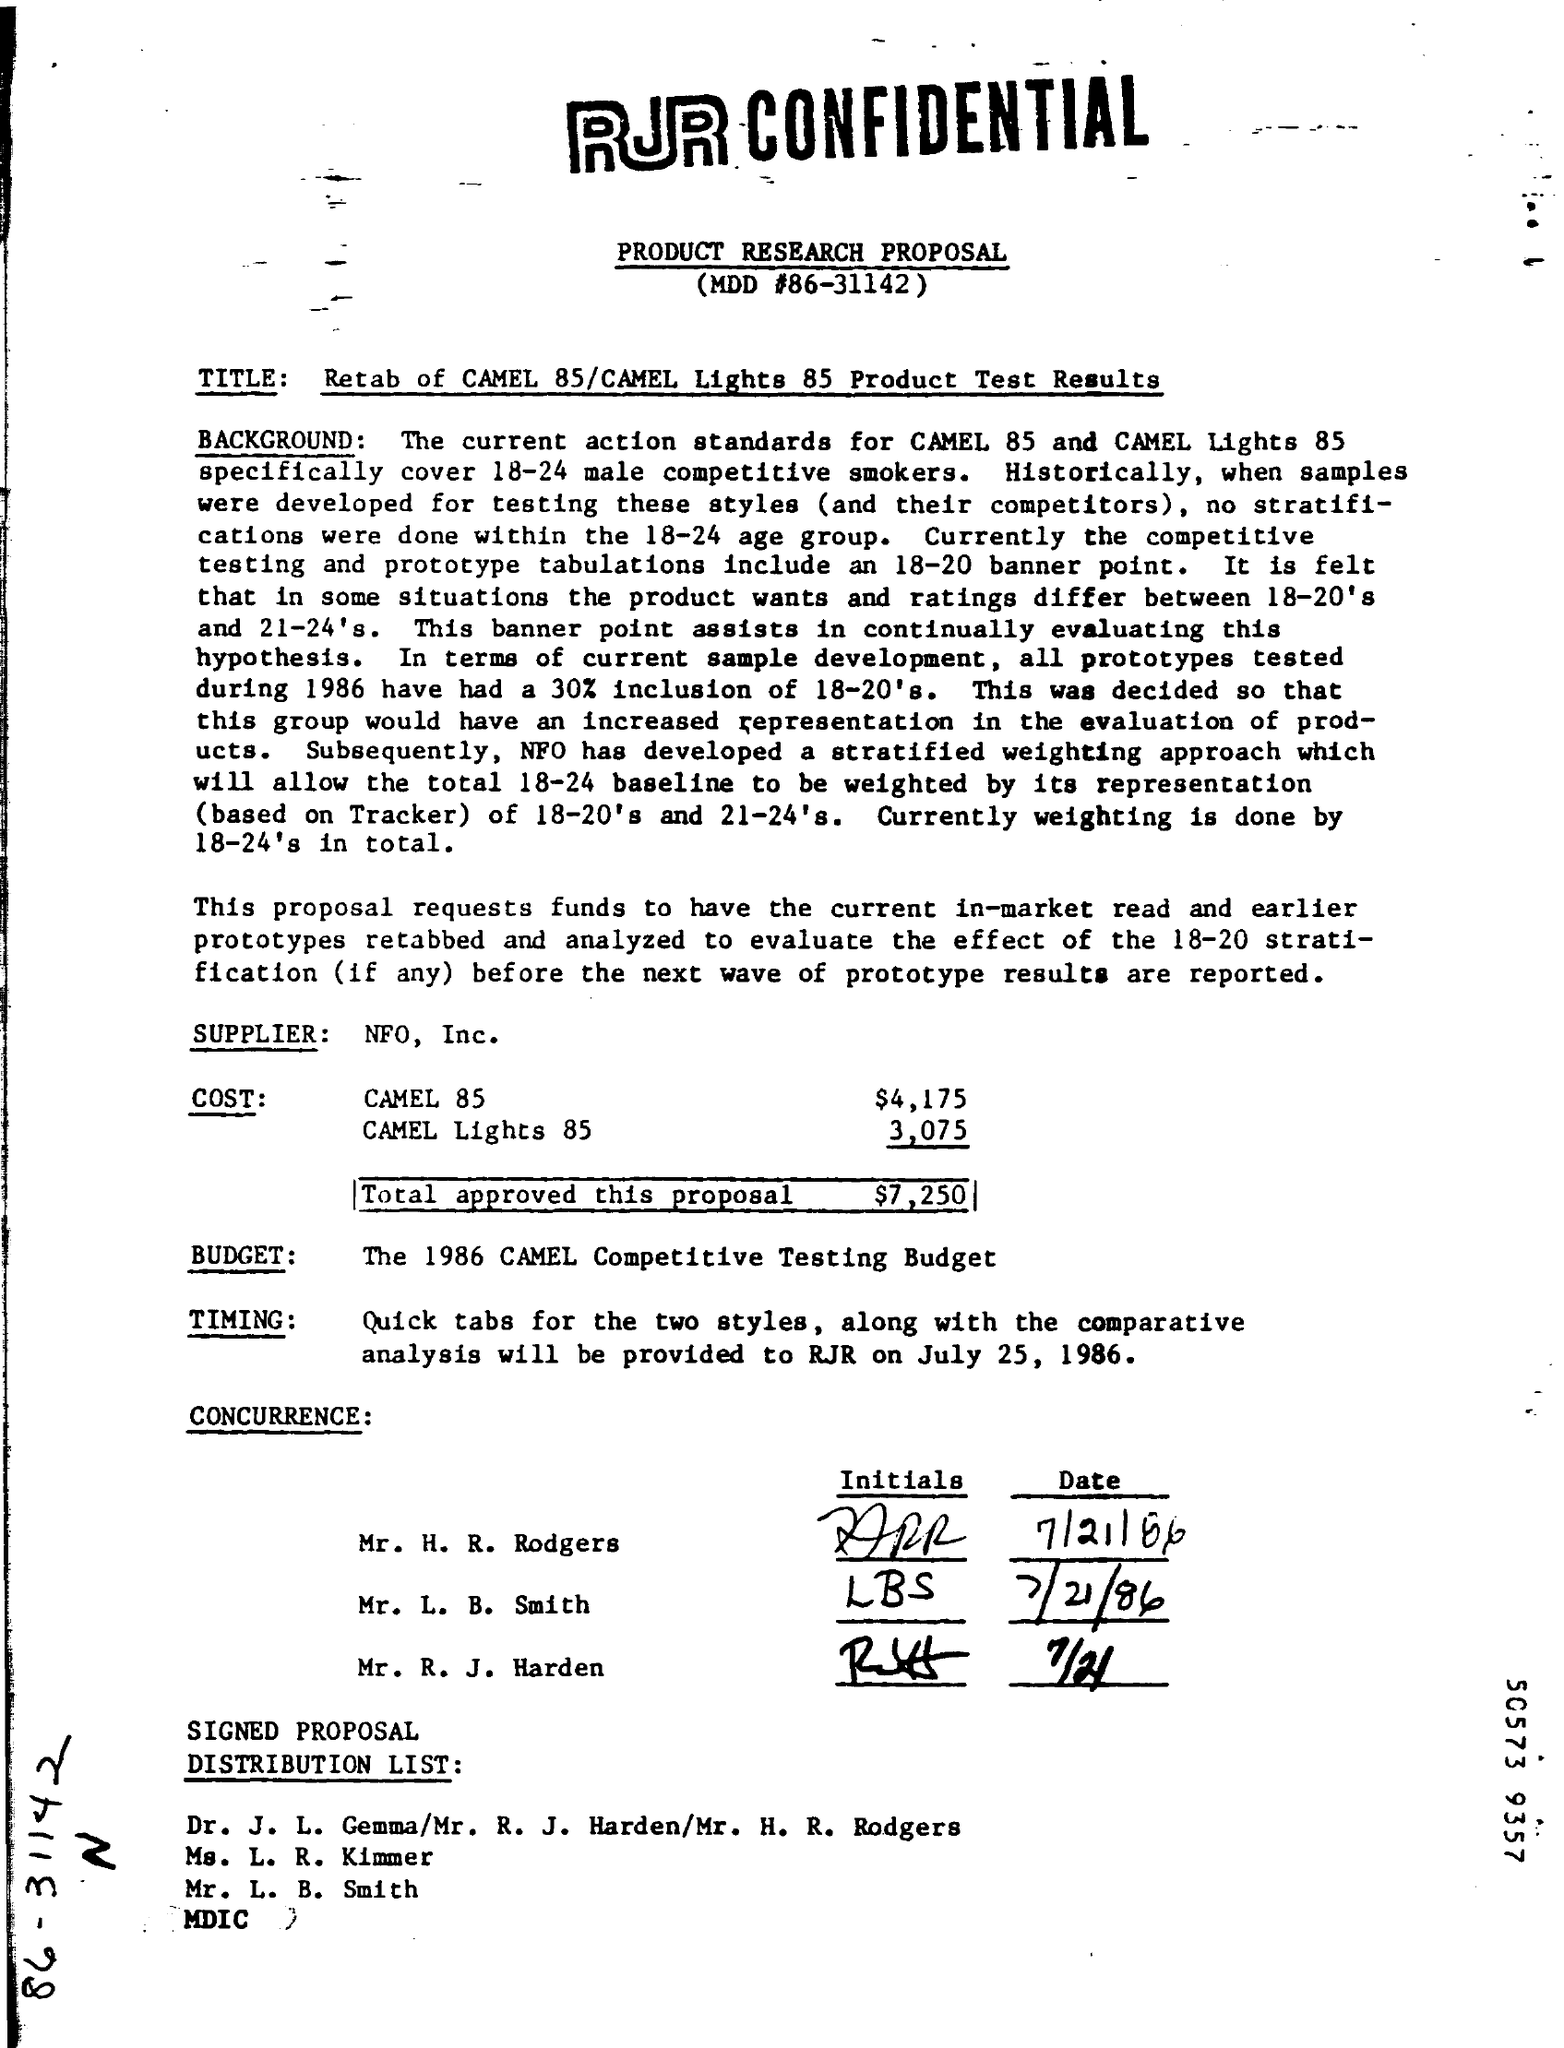Identify some key points in this picture. The total approved for this proposal is $7,250. The supplier of the information is NFO, Inc. The cost for a Camel 85 is $4,175. The cost for Camel Lights 85 is approximately $3,075. 